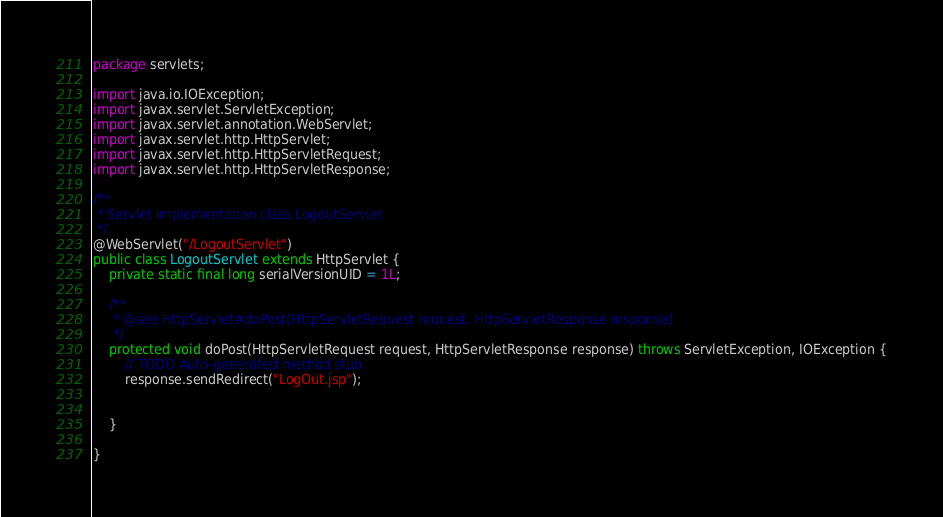<code> <loc_0><loc_0><loc_500><loc_500><_Java_>package servlets;

import java.io.IOException;
import javax.servlet.ServletException;
import javax.servlet.annotation.WebServlet;
import javax.servlet.http.HttpServlet;
import javax.servlet.http.HttpServletRequest;
import javax.servlet.http.HttpServletResponse;

/**
 * Servlet implementation class LogoutServlet
 */
@WebServlet("/LogoutServlet")
public class LogoutServlet extends HttpServlet {
	private static final long serialVersionUID = 1L;
       
  	/**
	 * @see HttpServlet#doPost(HttpServletRequest request, HttpServletResponse response)
	 */
	protected void doPost(HttpServletRequest request, HttpServletResponse response) throws ServletException, IOException {
		// TODO Auto-generated method stub
		response.sendRedirect("LogOut.jsp");
		
		
	}

}
</code> 